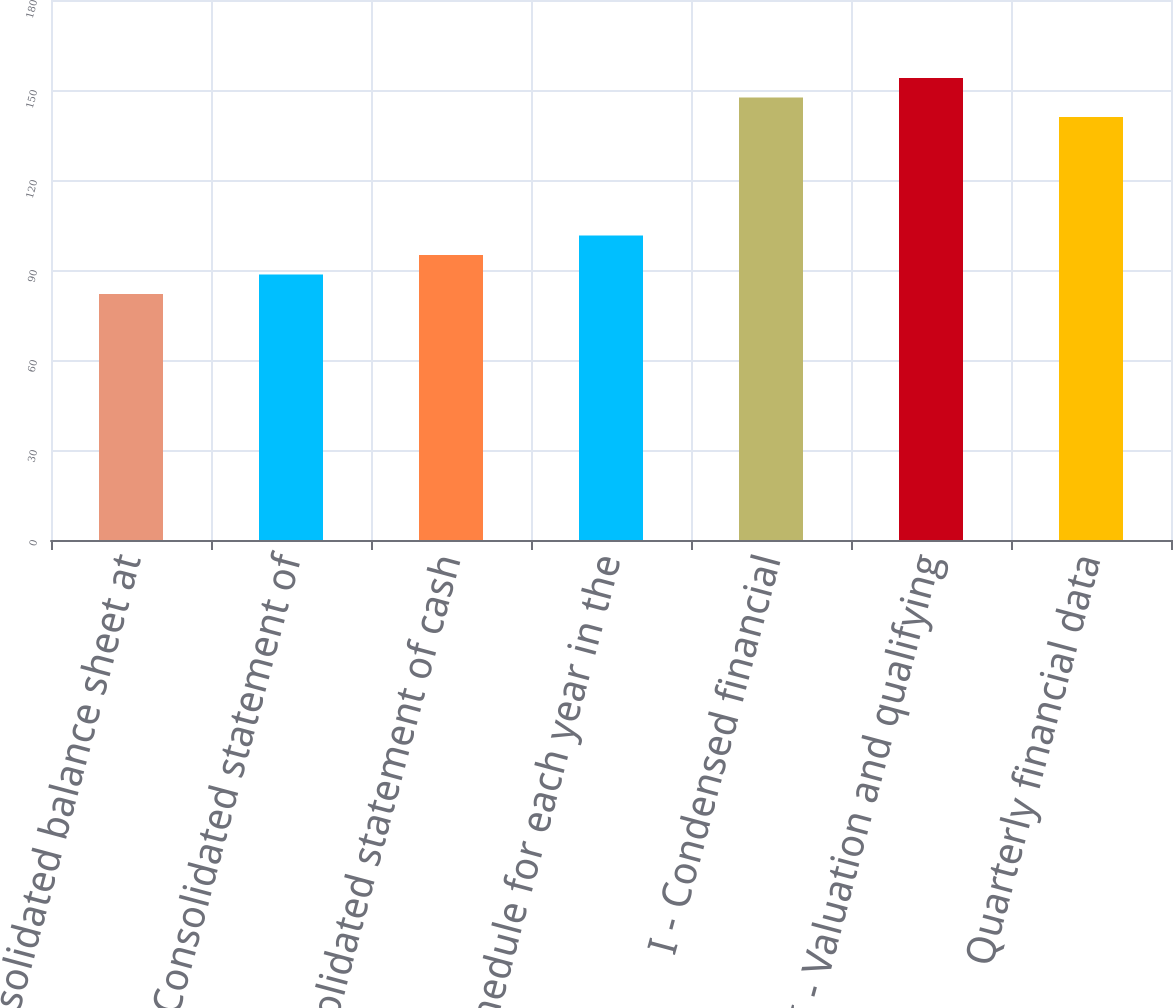<chart> <loc_0><loc_0><loc_500><loc_500><bar_chart><fcel>Consolidated balance sheet at<fcel>Consolidated statement of<fcel>Consolidated statement of cash<fcel>Schedule for each year in the<fcel>I - Condensed financial<fcel>II - Valuation and qualifying<fcel>Quarterly financial data<nl><fcel>82<fcel>88.5<fcel>95<fcel>101.5<fcel>147.5<fcel>154<fcel>141<nl></chart> 